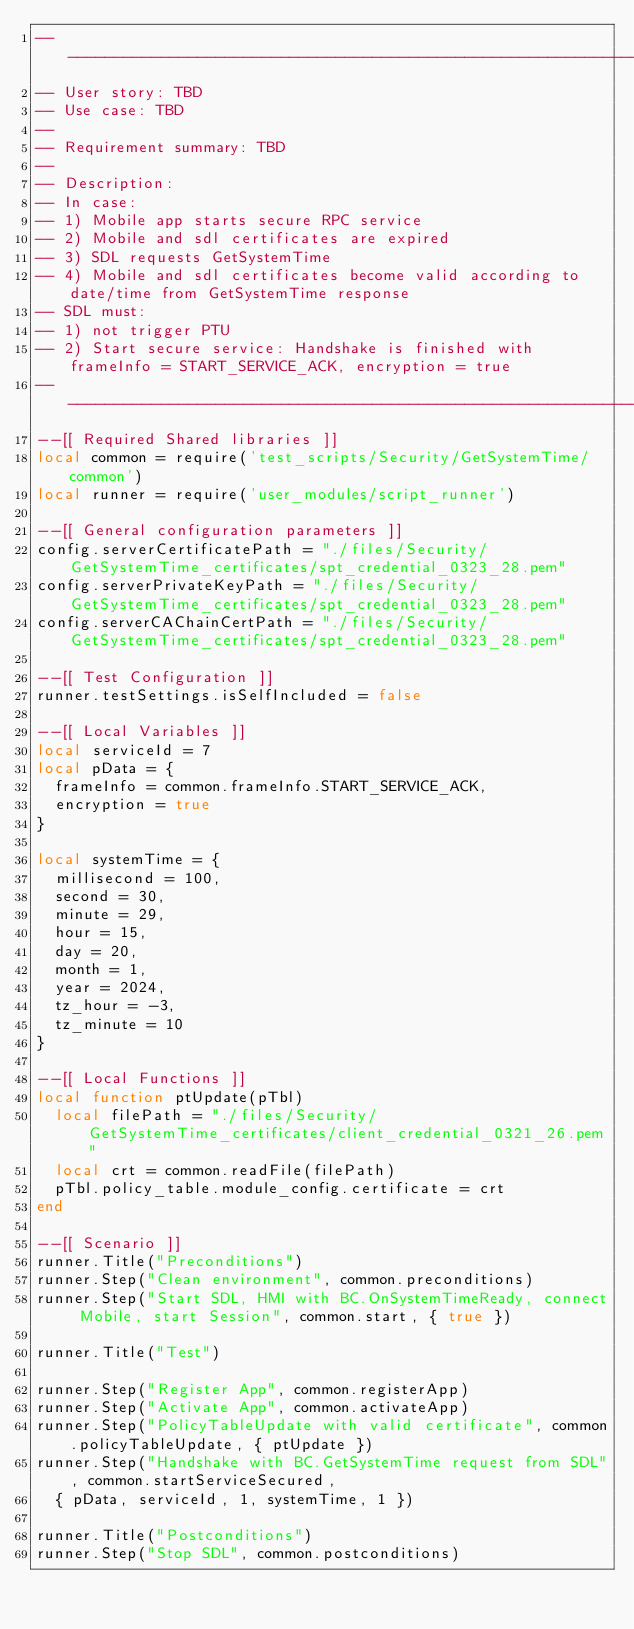Convert code to text. <code><loc_0><loc_0><loc_500><loc_500><_Lua_>---------------------------------------------------------------------------------------------------
-- User story: TBD
-- Use case: TBD
--
-- Requirement summary: TBD
--
-- Description:
-- In case:
-- 1) Mobile app starts secure RPC service
-- 2) Mobile and sdl certificates are expired
-- 3) SDL requests GetSystemTime
-- 4) Mobile and sdl certificates become valid according to date/time from GetSystemTime response
-- SDL must:
-- 1) not trigger PTU
-- 2) Start secure service: Handshake is finished with frameInfo = START_SERVICE_ACK, encryption = true
---------------------------------------------------------------------------------------------------
--[[ Required Shared libraries ]]
local common = require('test_scripts/Security/GetSystemTime/common')
local runner = require('user_modules/script_runner')

--[[ General configuration parameters ]]
config.serverCertificatePath = "./files/Security/GetSystemTime_certificates/spt_credential_0323_28.pem"
config.serverPrivateKeyPath = "./files/Security/GetSystemTime_certificates/spt_credential_0323_28.pem"
config.serverCAChainCertPath = "./files/Security/GetSystemTime_certificates/spt_credential_0323_28.pem"

--[[ Test Configuration ]]
runner.testSettings.isSelfIncluded = false

--[[ Local Variables ]]
local serviceId = 7
local pData = {
  frameInfo = common.frameInfo.START_SERVICE_ACK,
  encryption = true
}

local systemTime = {
  millisecond = 100,
  second = 30,
  minute = 29,
  hour = 15,
  day = 20,
  month = 1,
  year = 2024,
  tz_hour = -3,
  tz_minute = 10
}

--[[ Local Functions ]]
local function ptUpdate(pTbl)
  local filePath = "./files/Security/GetSystemTime_certificates/client_credential_0321_26.pem"
  local crt = common.readFile(filePath)
  pTbl.policy_table.module_config.certificate = crt
end

--[[ Scenario ]]
runner.Title("Preconditions")
runner.Step("Clean environment", common.preconditions)
runner.Step("Start SDL, HMI with BC.OnSystemTimeReady, connect Mobile, start Session", common.start, { true })

runner.Title("Test")

runner.Step("Register App", common.registerApp)
runner.Step("Activate App", common.activateApp)
runner.Step("PolicyTableUpdate with valid certificate", common.policyTableUpdate, { ptUpdate })
runner.Step("Handshake with BC.GetSystemTime request from SDL", common.startServiceSecured,
  { pData, serviceId, 1, systemTime, 1 })

runner.Title("Postconditions")
runner.Step("Stop SDL", common.postconditions)
</code> 